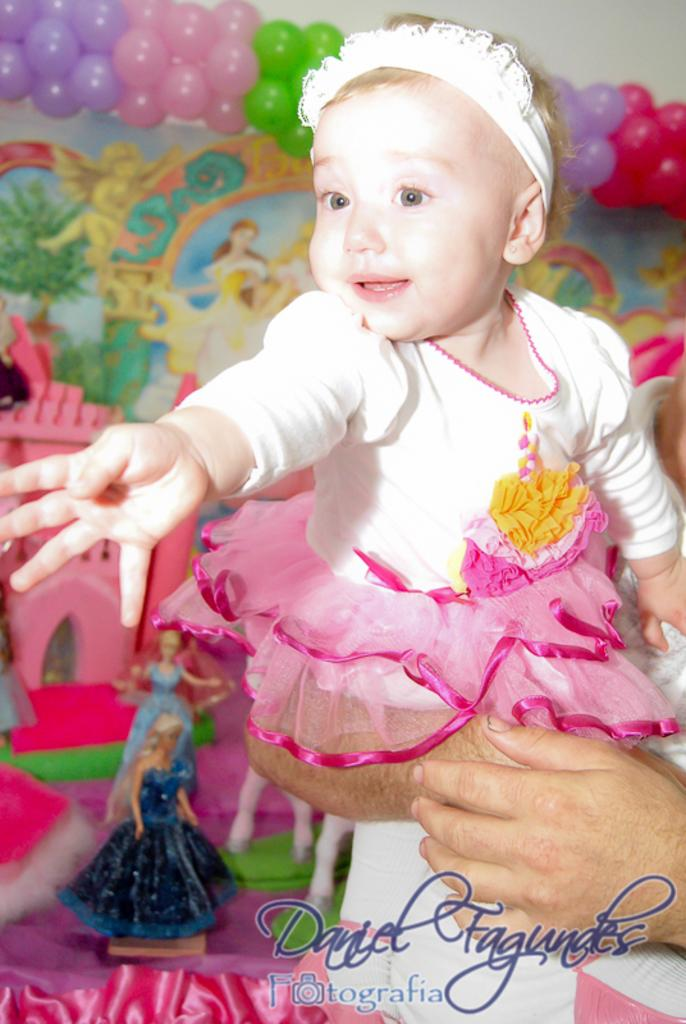What is the man in the image doing? The man is standing in the image and holding a baby in his hand. What can be seen in the background of the image? There are toys and decors in the background of the image. What is attached to the wall in the image? Balloons are placed on the wall at the top of the image. What type of current can be seen flowing through the cemetery in the image? There is no cemetery present in the image, and therefore no current can be observed. 